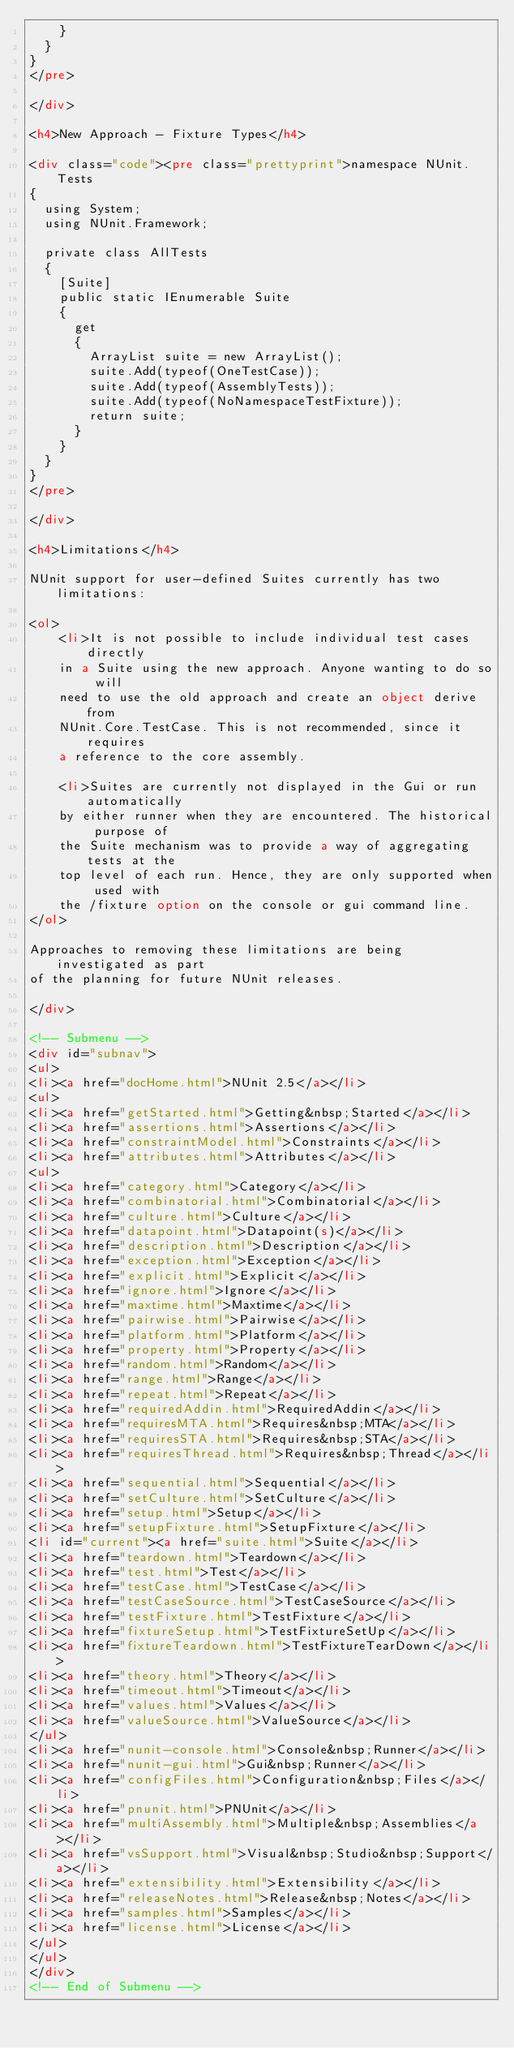Convert code to text. <code><loc_0><loc_0><loc_500><loc_500><_HTML_>    }
  }
}
</pre>

</div>

<h4>New Approach - Fixture Types</h4>

<div class="code"><pre class="prettyprint">namespace NUnit.Tests
{
  using System;
  using NUnit.Framework;

  private class AllTests
  {
    [Suite]
    public static IEnumerable Suite
    {
      get
      {
        ArrayList suite = new ArrayList();
        suite.Add(typeof(OneTestCase));
        suite.Add(typeof(AssemblyTests));
        suite.Add(typeof(NoNamespaceTestFixture));
        return suite;
      }
    }
  }
}
</pre>

</div>

<h4>Limitations</h4>

NUnit support for user-defined Suites currently has two limitations:

<ol>
	<li>It is not possible to include individual test cases directly
	in a Suite using the new approach. Anyone wanting to do so will
	need to use the old approach and create an object derive from
	NUnit.Core.TestCase. This is not recommended, since it requires
	a reference to the core assembly.

	<li>Suites are currently not displayed in the Gui or run automatically
	by either runner when they are encountered. The historical purpose of
	the Suite mechanism was to provide a way of aggregating tests at the
	top level of each run. Hence, they are only supported when used with
	the /fixture option on the console or gui command line.
</ol>

Approaches to removing these limitations are being investigated as part
of the planning for future NUnit releases.

</div>

<!-- Submenu -->
<div id="subnav">
<ul>
<li><a href="docHome.html">NUnit 2.5</a></li>
<ul>
<li><a href="getStarted.html">Getting&nbsp;Started</a></li>
<li><a href="assertions.html">Assertions</a></li>
<li><a href="constraintModel.html">Constraints</a></li>
<li><a href="attributes.html">Attributes</a></li>
<ul>
<li><a href="category.html">Category</a></li>
<li><a href="combinatorial.html">Combinatorial</a></li>
<li><a href="culture.html">Culture</a></li>
<li><a href="datapoint.html">Datapoint(s)</a></li>
<li><a href="description.html">Description</a></li>
<li><a href="exception.html">Exception</a></li>
<li><a href="explicit.html">Explicit</a></li>
<li><a href="ignore.html">Ignore</a></li>
<li><a href="maxtime.html">Maxtime</a></li>
<li><a href="pairwise.html">Pairwise</a></li>
<li><a href="platform.html">Platform</a></li>
<li><a href="property.html">Property</a></li>
<li><a href="random.html">Random</a></li>
<li><a href="range.html">Range</a></li>
<li><a href="repeat.html">Repeat</a></li>
<li><a href="requiredAddin.html">RequiredAddin</a></li>
<li><a href="requiresMTA.html">Requires&nbsp;MTA</a></li>
<li><a href="requiresSTA.html">Requires&nbsp;STA</a></li>
<li><a href="requiresThread.html">Requires&nbsp;Thread</a></li>
<li><a href="sequential.html">Sequential</a></li>
<li><a href="setCulture.html">SetCulture</a></li>
<li><a href="setup.html">Setup</a></li>
<li><a href="setupFixture.html">SetupFixture</a></li>
<li id="current"><a href="suite.html">Suite</a></li>
<li><a href="teardown.html">Teardown</a></li>
<li><a href="test.html">Test</a></li>
<li><a href="testCase.html">TestCase</a></li>
<li><a href="testCaseSource.html">TestCaseSource</a></li>
<li><a href="testFixture.html">TestFixture</a></li>
<li><a href="fixtureSetup.html">TestFixtureSetUp</a></li>
<li><a href="fixtureTeardown.html">TestFixtureTearDown</a></li>
<li><a href="theory.html">Theory</a></li>
<li><a href="timeout.html">Timeout</a></li>
<li><a href="values.html">Values</a></li>
<li><a href="valueSource.html">ValueSource</a></li>
</ul>
<li><a href="nunit-console.html">Console&nbsp;Runner</a></li>
<li><a href="nunit-gui.html">Gui&nbsp;Runner</a></li>
<li><a href="configFiles.html">Configuration&nbsp;Files</a></li>
<li><a href="pnunit.html">PNUnit</a></li>
<li><a href="multiAssembly.html">Multiple&nbsp;Assemblies</a></li>
<li><a href="vsSupport.html">Visual&nbsp;Studio&nbsp;Support</a></li>
<li><a href="extensibility.html">Extensibility</a></li>
<li><a href="releaseNotes.html">Release&nbsp;Notes</a></li>
<li><a href="samples.html">Samples</a></li>
<li><a href="license.html">License</a></li>
</ul>
</ul>
</div>
<!-- End of Submenu -->


</code> 